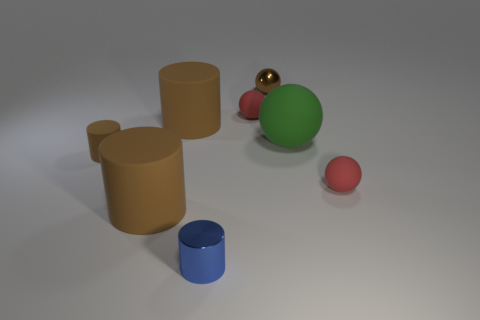Subtract all blue balls. How many brown cylinders are left? 3 Subtract 1 cylinders. How many cylinders are left? 3 Add 2 big brown rubber cylinders. How many objects exist? 10 Subtract 0 purple blocks. How many objects are left? 8 Subtract all large brown rubber spheres. Subtract all big brown objects. How many objects are left? 6 Add 7 green spheres. How many green spheres are left? 8 Add 7 blue rubber spheres. How many blue rubber spheres exist? 7 